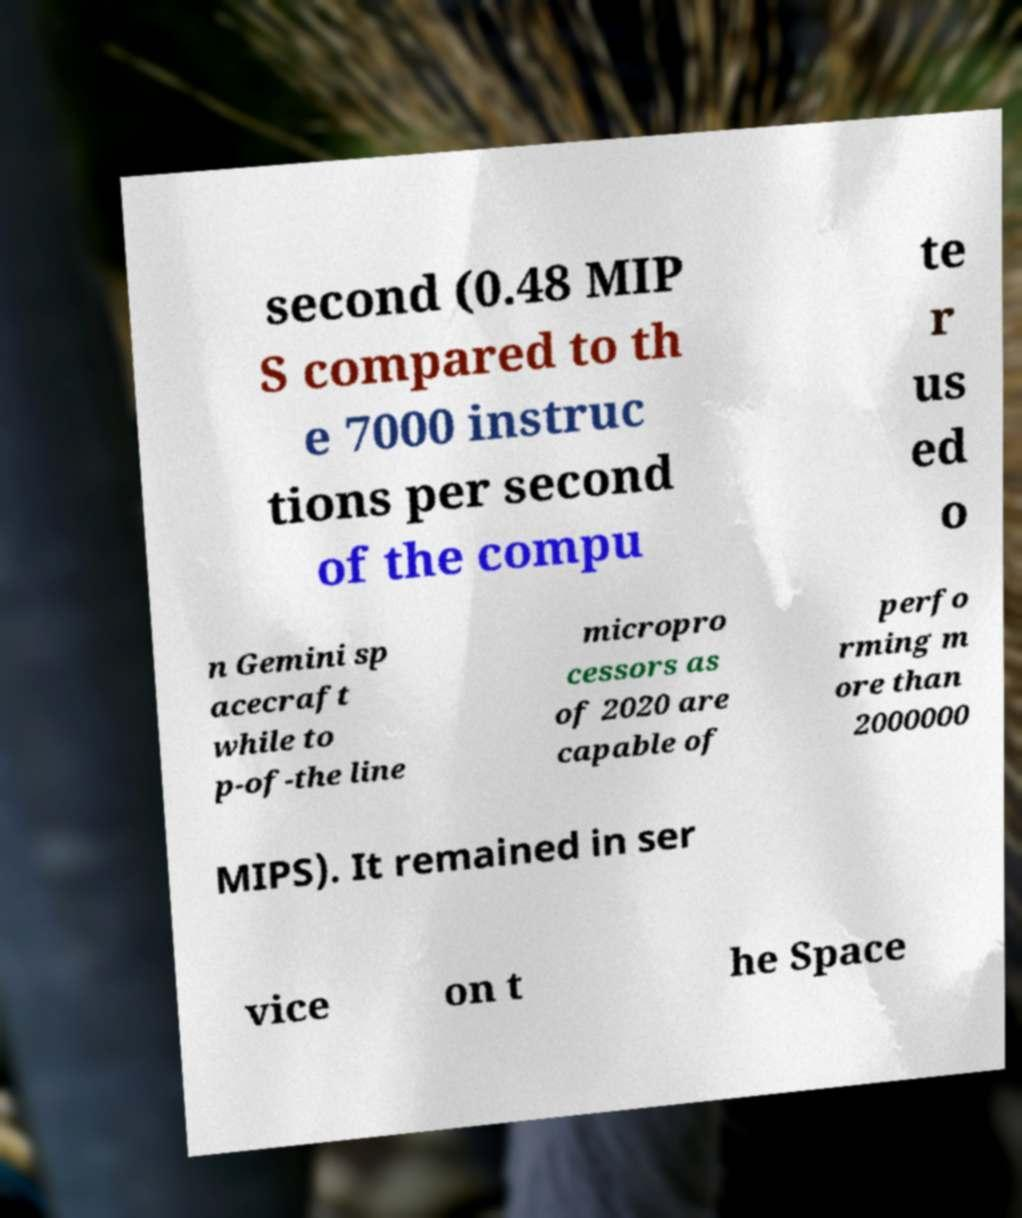For documentation purposes, I need the text within this image transcribed. Could you provide that? second (0.48 MIP S compared to th e 7000 instruc tions per second of the compu te r us ed o n Gemini sp acecraft while to p-of-the line micropro cessors as of 2020 are capable of perfo rming m ore than 2000000 MIPS). It remained in ser vice on t he Space 